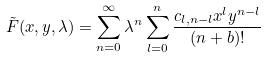Convert formula to latex. <formula><loc_0><loc_0><loc_500><loc_500>\tilde { F } ( x , y , \lambda ) = \sum _ { n = 0 } ^ { \infty } \lambda ^ { n } \sum _ { l = 0 } ^ { n } { \frac { c _ { l , n - l } x ^ { l } y ^ { n - l } } { ( n + b ) ! } }</formula> 